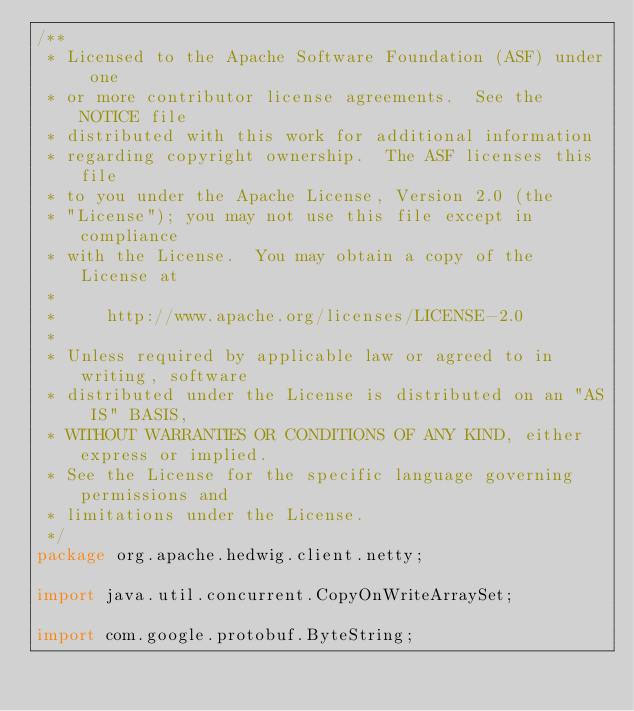Convert code to text. <code><loc_0><loc_0><loc_500><loc_500><_Java_>/**
 * Licensed to the Apache Software Foundation (ASF) under one
 * or more contributor license agreements.  See the NOTICE file
 * distributed with this work for additional information
 * regarding copyright ownership.  The ASF licenses this file
 * to you under the Apache License, Version 2.0 (the
 * "License"); you may not use this file except in compliance
 * with the License.  You may obtain a copy of the License at
 *
 *     http://www.apache.org/licenses/LICENSE-2.0
 *
 * Unless required by applicable law or agreed to in writing, software
 * distributed under the License is distributed on an "AS IS" BASIS,
 * WITHOUT WARRANTIES OR CONDITIONS OF ANY KIND, either express or implied.
 * See the License for the specific language governing permissions and
 * limitations under the License.
 */
package org.apache.hedwig.client.netty;

import java.util.concurrent.CopyOnWriteArraySet;

import com.google.protobuf.ByteString;
</code> 